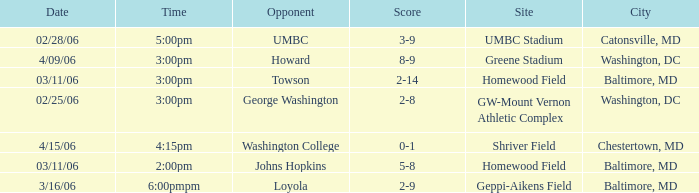Which Score has a Time of 5:00pm? 3-9. 